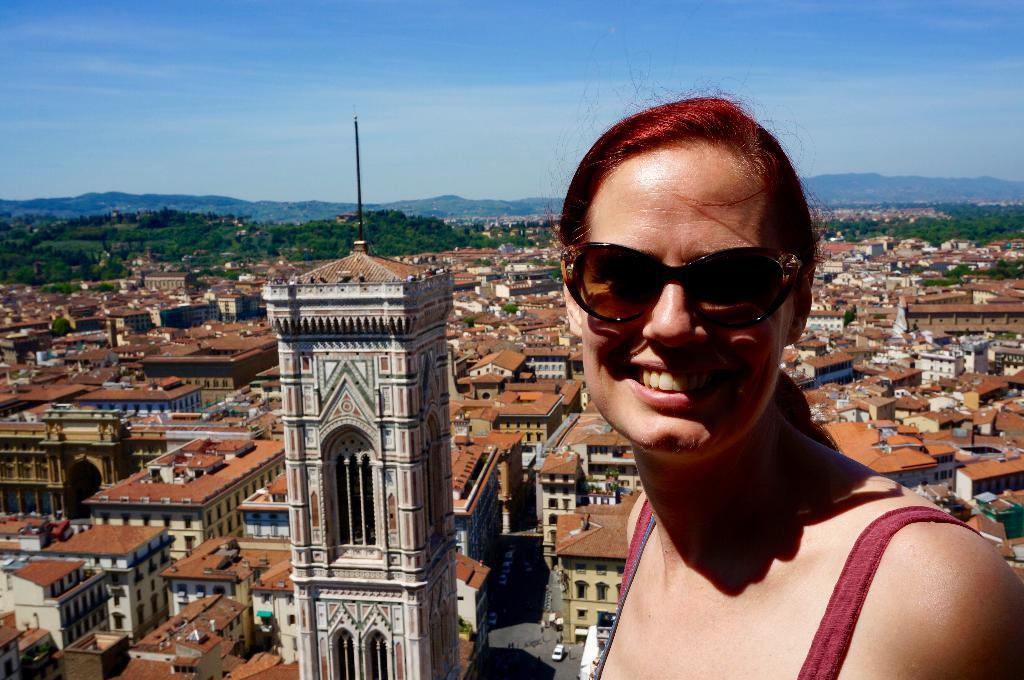What type of structures can be seen in the image? There are buildings in the image. What feature can be observed on the buildings? There are windows in the image. What type of natural elements are visible in the background of the image? There are trees in the background of the image. Who is the person in the front of the image? There is a woman wearing goggles in the front of the image. What is visible at the top of the image? The sky is visible at the top of the image. What is the result of the addition problem written on the woman's forehead in the image? There is no addition problem written on the woman's forehead in the image. How does the woman's breath affect the surrounding environment in the image? The image does not provide any information about the woman's breath or its effect on the environment. 